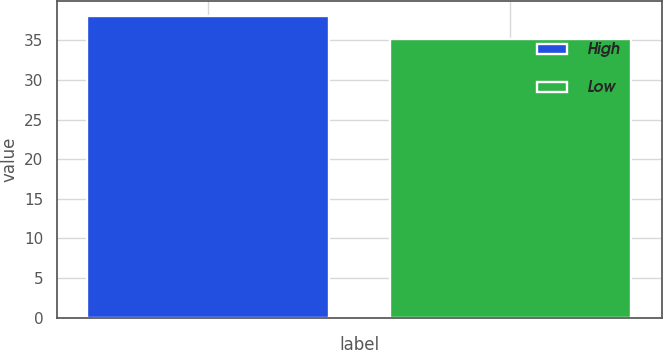Convert chart to OTSL. <chart><loc_0><loc_0><loc_500><loc_500><bar_chart><fcel>High<fcel>Low<nl><fcel>38.03<fcel>35.12<nl></chart> 